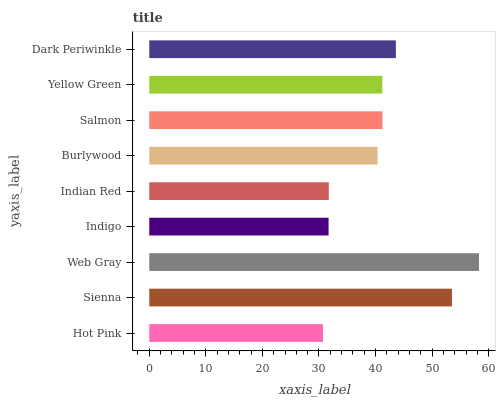Is Hot Pink the minimum?
Answer yes or no. Yes. Is Web Gray the maximum?
Answer yes or no. Yes. Is Sienna the minimum?
Answer yes or no. No. Is Sienna the maximum?
Answer yes or no. No. Is Sienna greater than Hot Pink?
Answer yes or no. Yes. Is Hot Pink less than Sienna?
Answer yes or no. Yes. Is Hot Pink greater than Sienna?
Answer yes or no. No. Is Sienna less than Hot Pink?
Answer yes or no. No. Is Yellow Green the high median?
Answer yes or no. Yes. Is Yellow Green the low median?
Answer yes or no. Yes. Is Indigo the high median?
Answer yes or no. No. Is Indian Red the low median?
Answer yes or no. No. 